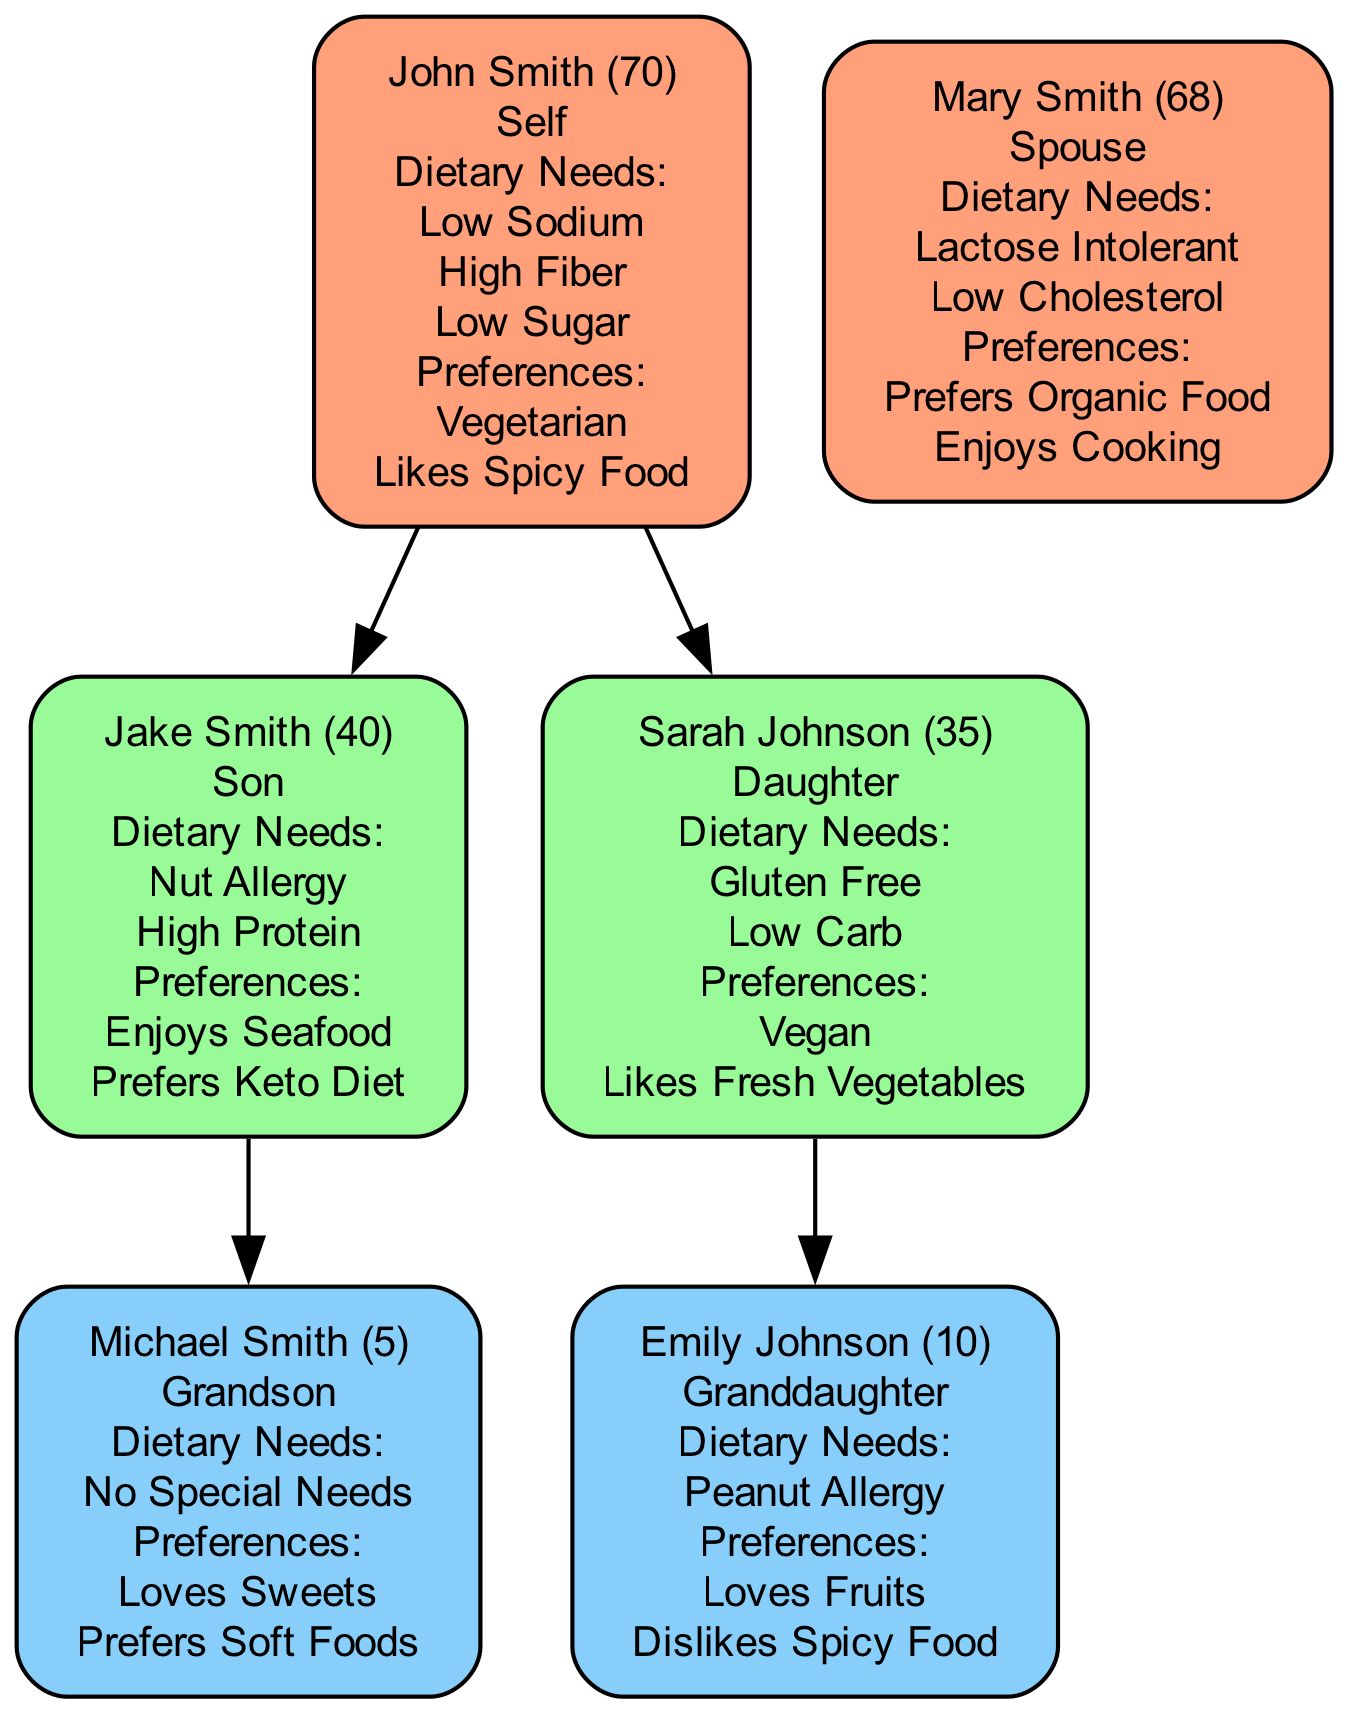What are John Smith's dietary needs? To find John Smith's dietary needs, locate his node in the diagram. The dietary needs listed under his name are "Low Sodium," "High Fiber," and "Low Sugar."
Answer: Low Sodium, High Fiber, Low Sugar Who is Mary Smith's relationship to John Smith? To determine Mary Smith's relationship to John Smith, find her node and observe the connection. She is identified as "Spouse" in relation to John Smith.
Answer: Spouse How many children do John and Mary Smith have? To answer this, count the nodes directly connected to John Smith labeled as "Son" and "Daughter." There are two children: Jake Smith and Sarah Johnson.
Answer: 2 What dietary preference does Jake Smith have? Locate Jake Smith's node. Under preferences, his dietary preference is listed as "Enjoys Seafood" and "Prefers Keto Diet." Therefore, one of them can be selected.
Answer: Enjoys Seafood Which family member has a peanut allergy? To find the family member with a peanut allergy, examine each member’s dietary needs. Emily Johnson is the one with "Peanut Allergy" listed under her dietary needs.
Answer: Emily Johnson Is Sarah Johnson's dietary preference vegan? To find this, look at Sarah Johnson's node. Her preferences include "Vegan," confirming that she follows this dietary preference.
Answer: Yes How many members of the family tree are grandchildren? Analyze the nodes for generations. Both Emily Johnson and Michael Smith are listed as grandchildren of John Smith. Therefore, count these nodes to arrive at the total.
Answer: 2 What dietary need is unique to Mary Smith? To answer this, look at Mary's dietary needs in her node. The need "Lactose Intolerant" is unique to her, as no other family members share this dietary requirement.
Answer: Lactose Intolerant Which family member dislikes spicy food? Find the node for Emily Johnson and check her preferences. It states "Dislikes Spicy Food," indicating that she is the family member with this preference.
Answer: Emily Johnson 